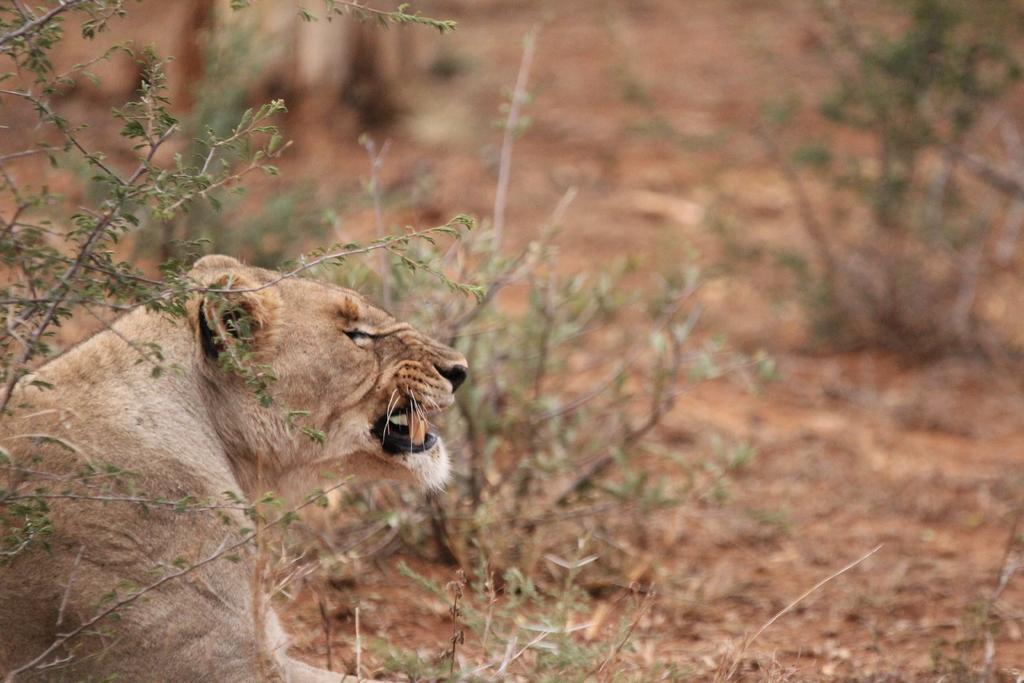How would you summarize this image in a sentence or two? In this picture, we see the lion and it is roaring. Behind that, we see the trees. At the bottom, we see the soil, dry leaves and twigs. In the background, it is brown in color. This picture is blurred in the background. 